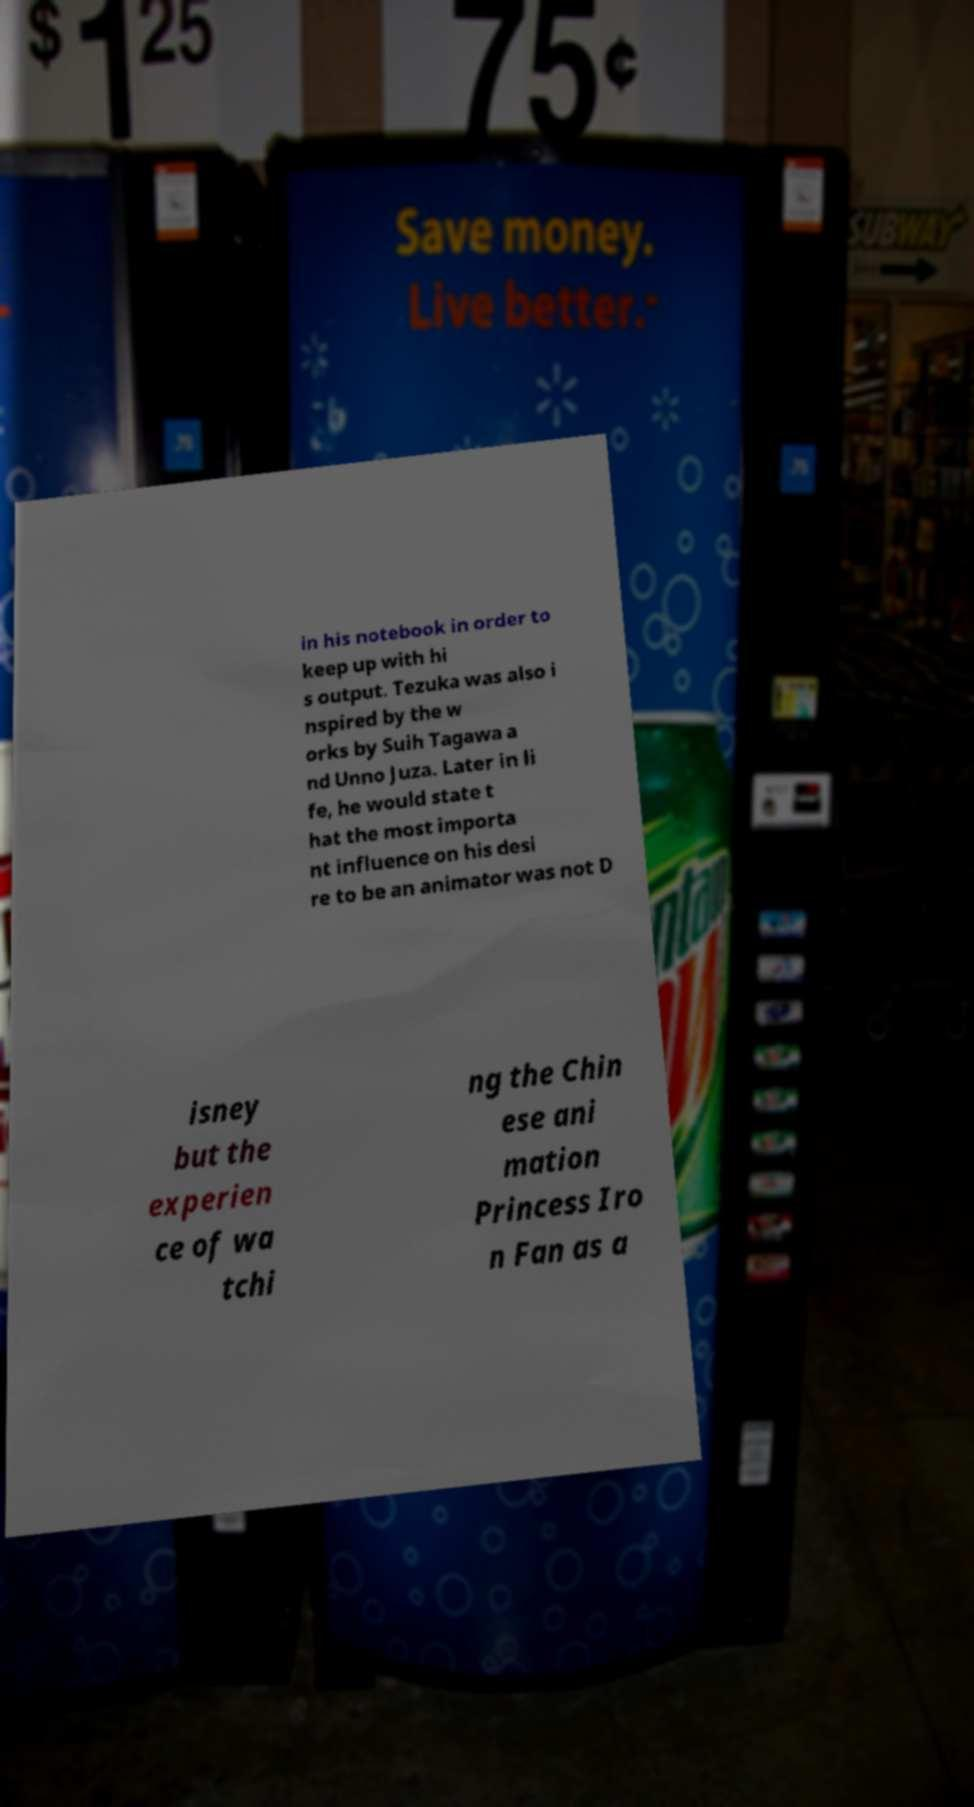Could you extract and type out the text from this image? in his notebook in order to keep up with hi s output. Tezuka was also i nspired by the w orks by Suih Tagawa a nd Unno Juza. Later in li fe, he would state t hat the most importa nt influence on his desi re to be an animator was not D isney but the experien ce of wa tchi ng the Chin ese ani mation Princess Iro n Fan as a 